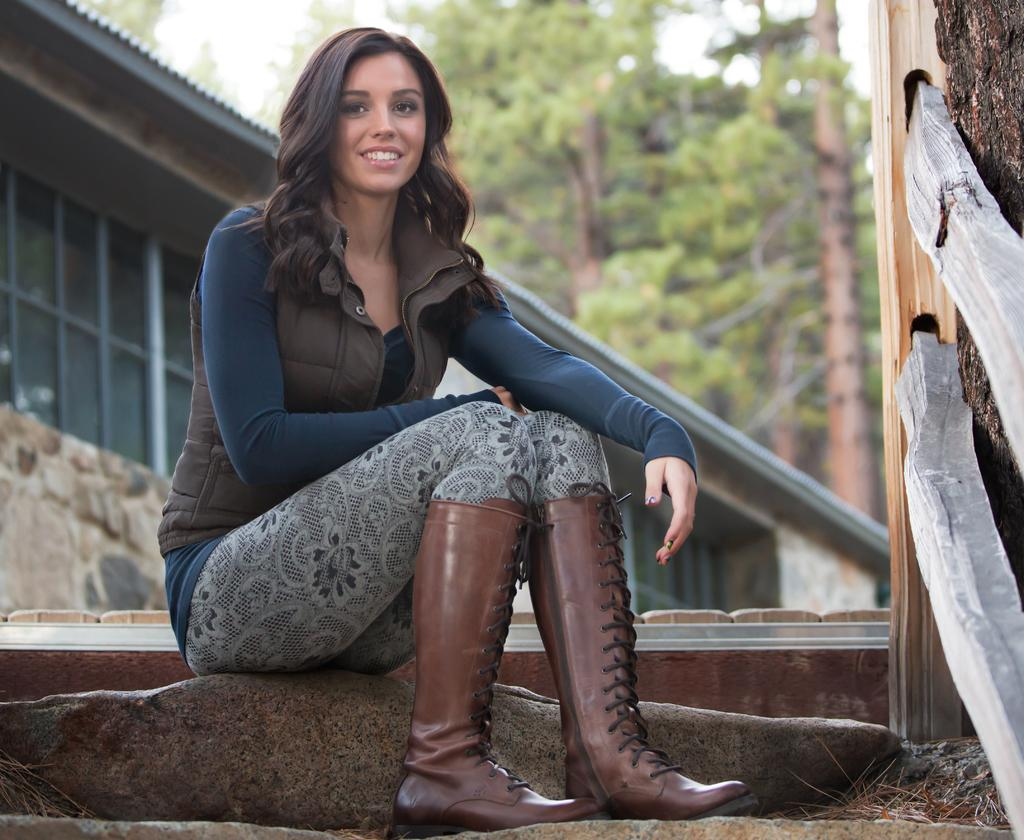Who is present in the image? There is a woman in the image. What is the woman wearing? The woman is wearing a jacket. What is the woman's facial expression? The woman is smiling. Where is the woman sitting? The woman is sitting on a rock. What type of structure can be seen in the image? There is a building with windows in the image. What can be seen in the background of the image? Trees are visible in the background of the image. How many men are rowing the boat in the image? There are no men or boats present in the image. How many kittens are playing on the woman's lap in the image? There are no kittens present in the image. 